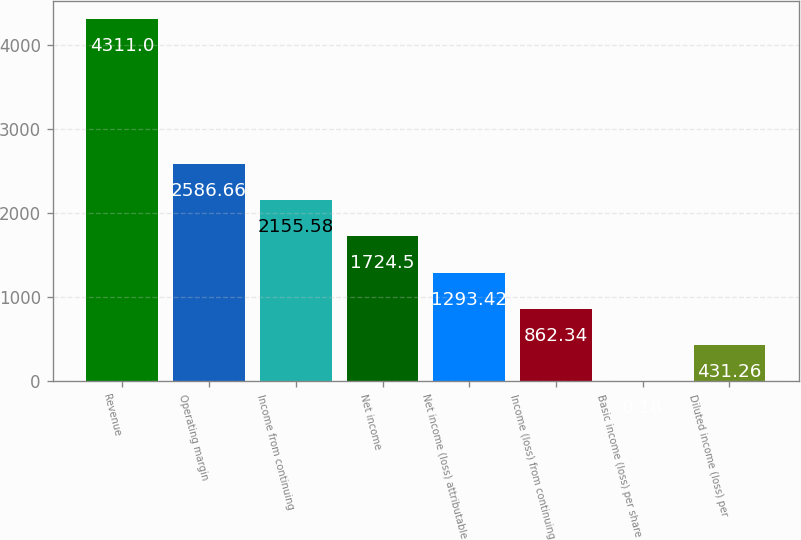<chart> <loc_0><loc_0><loc_500><loc_500><bar_chart><fcel>Revenue<fcel>Operating margin<fcel>Income from continuing<fcel>Net income<fcel>Net income (loss) attributable<fcel>Income (loss) from continuing<fcel>Basic income (loss) per share<fcel>Diluted income (loss) per<nl><fcel>4311<fcel>2586.66<fcel>2155.58<fcel>1724.5<fcel>1293.42<fcel>862.34<fcel>0.18<fcel>431.26<nl></chart> 